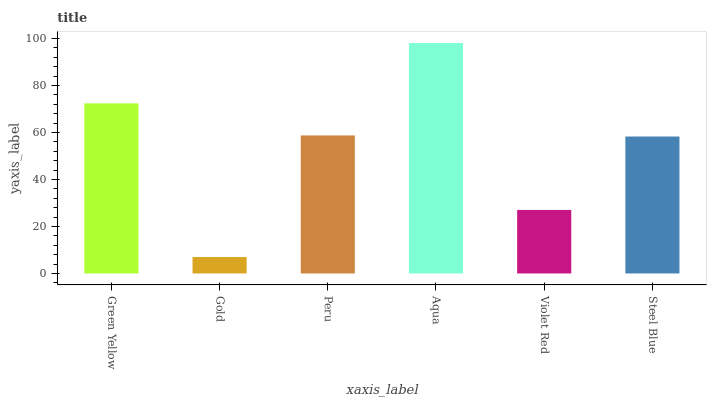Is Gold the minimum?
Answer yes or no. Yes. Is Aqua the maximum?
Answer yes or no. Yes. Is Peru the minimum?
Answer yes or no. No. Is Peru the maximum?
Answer yes or no. No. Is Peru greater than Gold?
Answer yes or no. Yes. Is Gold less than Peru?
Answer yes or no. Yes. Is Gold greater than Peru?
Answer yes or no. No. Is Peru less than Gold?
Answer yes or no. No. Is Peru the high median?
Answer yes or no. Yes. Is Steel Blue the low median?
Answer yes or no. Yes. Is Steel Blue the high median?
Answer yes or no. No. Is Green Yellow the low median?
Answer yes or no. No. 